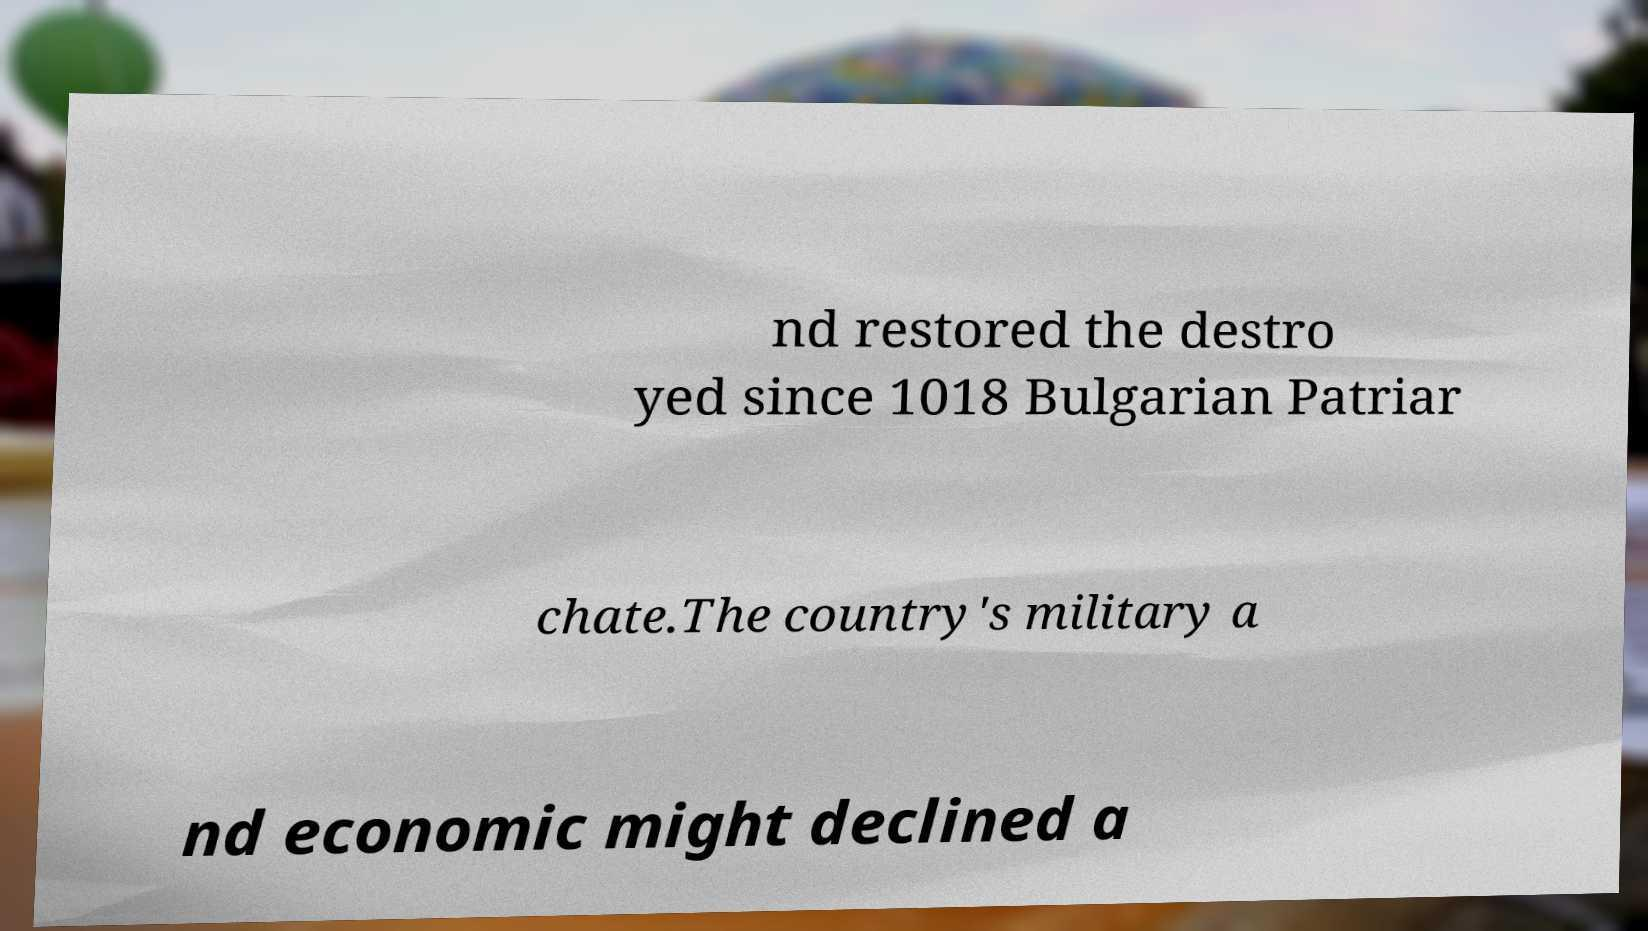There's text embedded in this image that I need extracted. Can you transcribe it verbatim? nd restored the destro yed since 1018 Bulgarian Patriar chate.The country's military a nd economic might declined a 